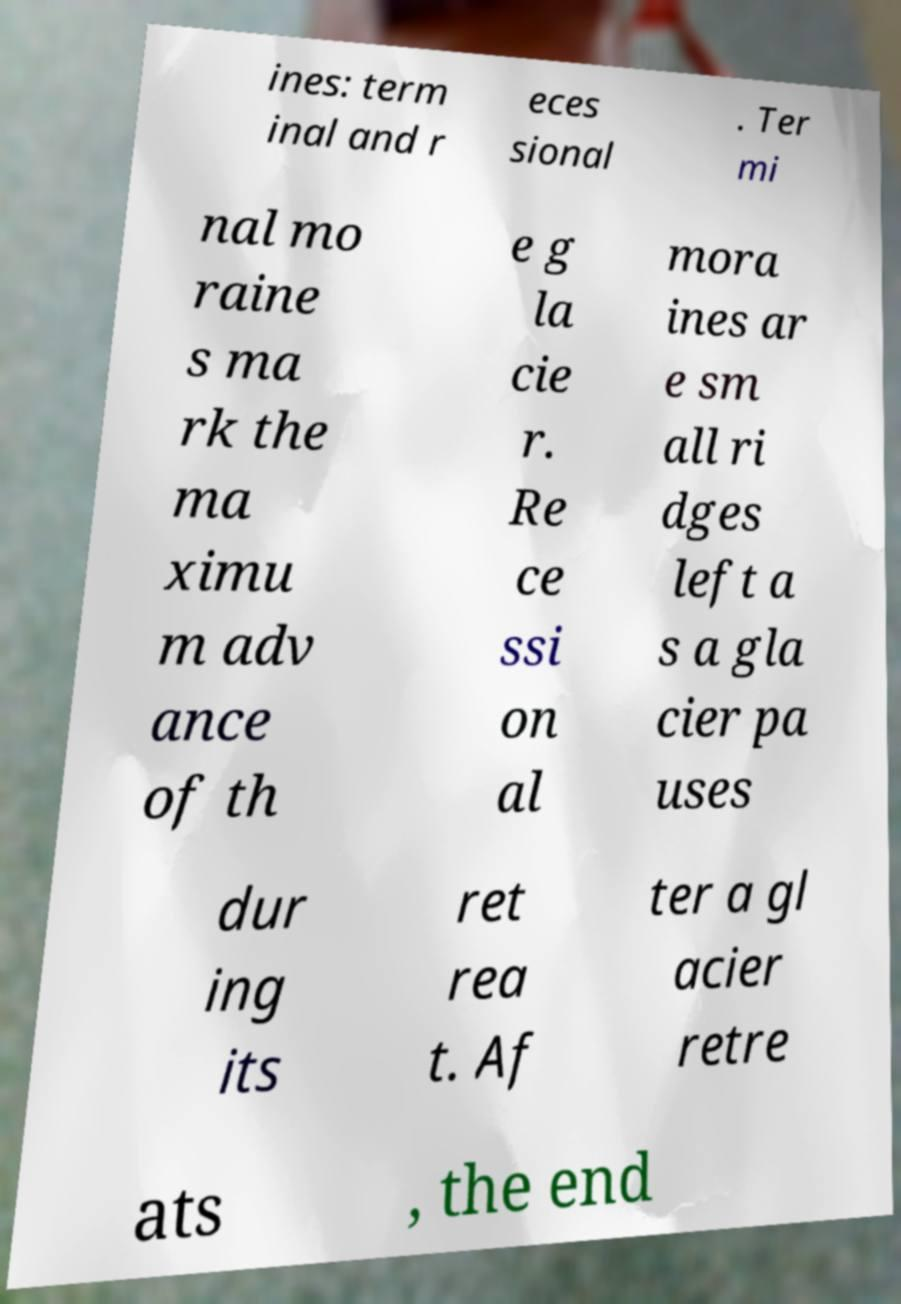What messages or text are displayed in this image? I need them in a readable, typed format. ines: term inal and r eces sional . Ter mi nal mo raine s ma rk the ma ximu m adv ance of th e g la cie r. Re ce ssi on al mora ines ar e sm all ri dges left a s a gla cier pa uses dur ing its ret rea t. Af ter a gl acier retre ats , the end 